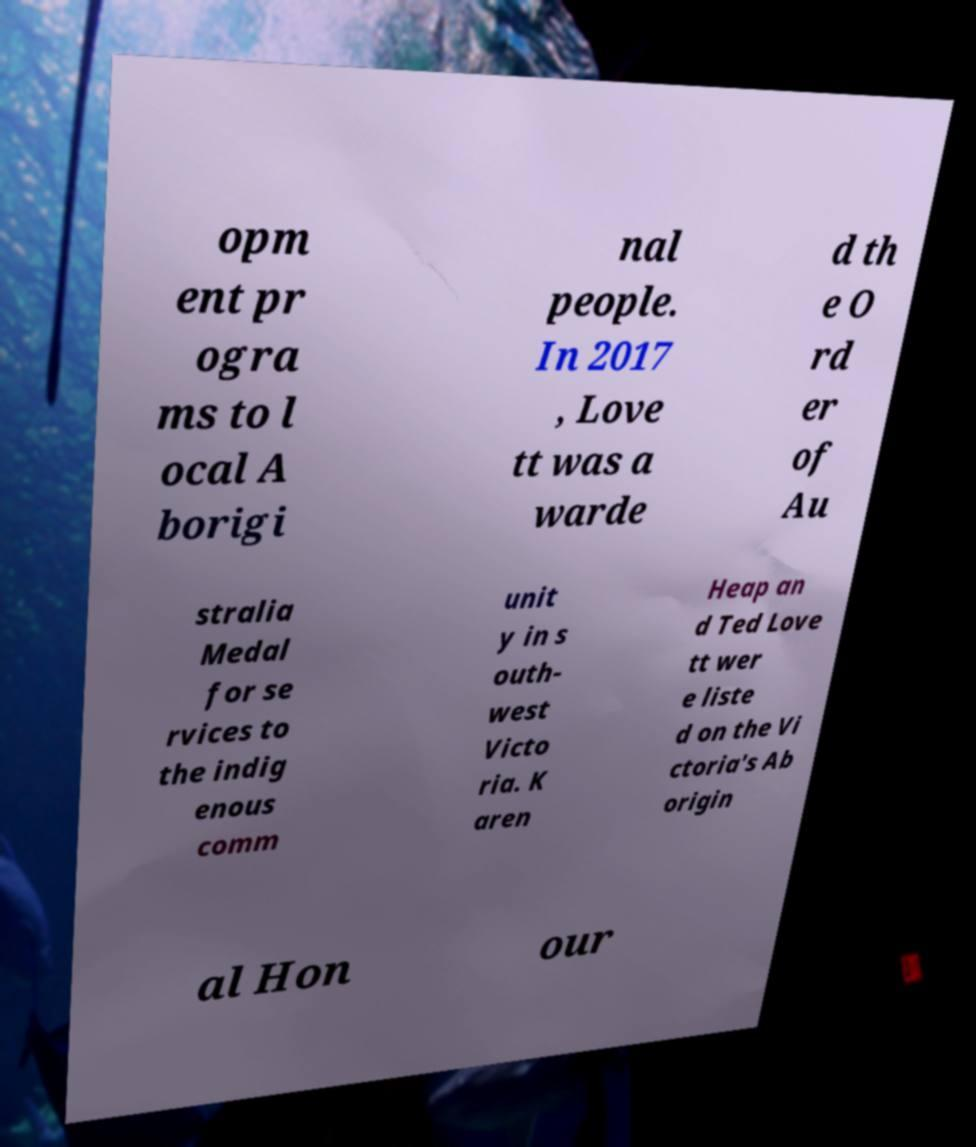I need the written content from this picture converted into text. Can you do that? opm ent pr ogra ms to l ocal A borigi nal people. In 2017 , Love tt was a warde d th e O rd er of Au stralia Medal for se rvices to the indig enous comm unit y in s outh- west Victo ria. K aren Heap an d Ted Love tt wer e liste d on the Vi ctoria's Ab origin al Hon our 